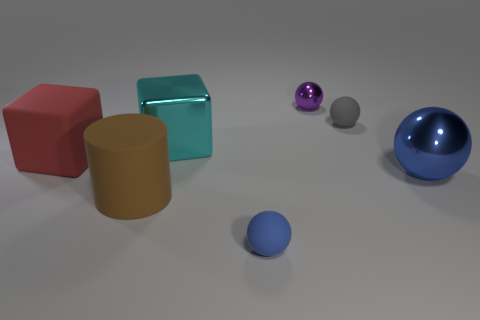Does the big cylinder that is left of the small blue thing have the same material as the large red block?
Your answer should be compact. Yes. Is the number of gray things that are on the left side of the red object greater than the number of objects behind the large blue sphere?
Offer a terse response. No. What material is the cyan cube that is the same size as the matte cylinder?
Offer a terse response. Metal. How many other things are there of the same material as the red thing?
Provide a succinct answer. 3. Does the metal object in front of the large shiny cube have the same shape as the small thing left of the small metallic thing?
Offer a very short reply. Yes. What number of other objects are there of the same color as the big ball?
Make the answer very short. 1. Is the object that is in front of the big cylinder made of the same material as the tiny sphere on the right side of the purple metal ball?
Keep it short and to the point. Yes. Is the number of tiny gray rubber balls to the left of the large red rubber thing the same as the number of tiny objects that are behind the big cyan thing?
Your answer should be very brief. No. What is the tiny thing in front of the big shiny cube made of?
Your response must be concise. Rubber. Are there fewer big cyan metal things than red rubber cylinders?
Your answer should be very brief. No. 